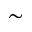Convert formula to latex. <formula><loc_0><loc_0><loc_500><loc_500>\sim</formula> 